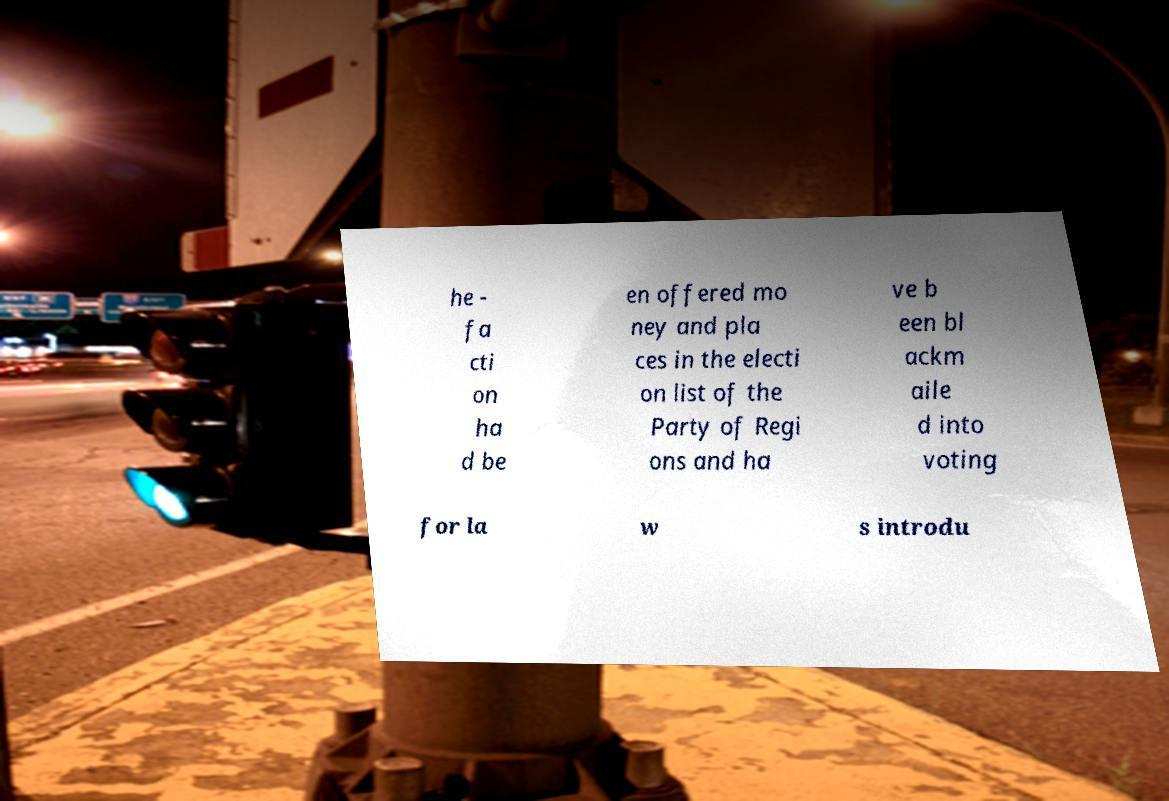Can you accurately transcribe the text from the provided image for me? he - fa cti on ha d be en offered mo ney and pla ces in the electi on list of the Party of Regi ons and ha ve b een bl ackm aile d into voting for la w s introdu 